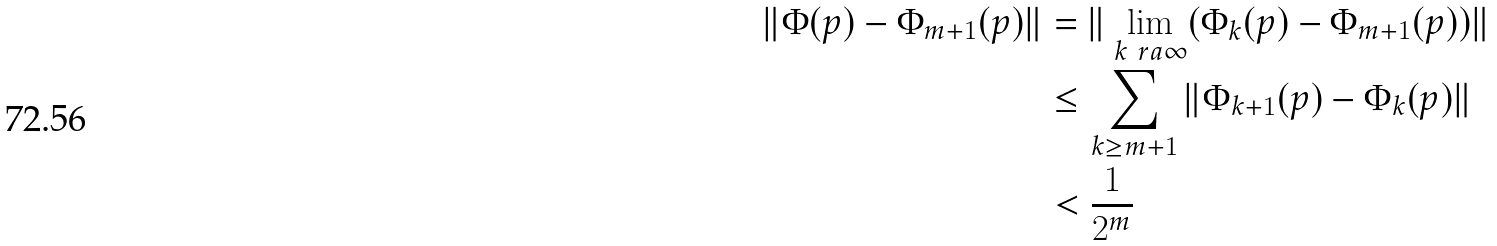Convert formula to latex. <formula><loc_0><loc_0><loc_500><loc_500>\| \Phi ( p ) - \Phi _ { m + 1 } ( p ) \| & = \| \lim _ { k \ r a \infty } ( \Phi _ { k } ( p ) - \Phi _ { m + 1 } ( p ) ) \| \\ & \leq \sum _ { k \geq m + 1 } \| \Phi _ { k + 1 } ( p ) - \Phi _ { k } ( p ) \| \\ & < \frac { 1 } { 2 ^ { m } }</formula> 